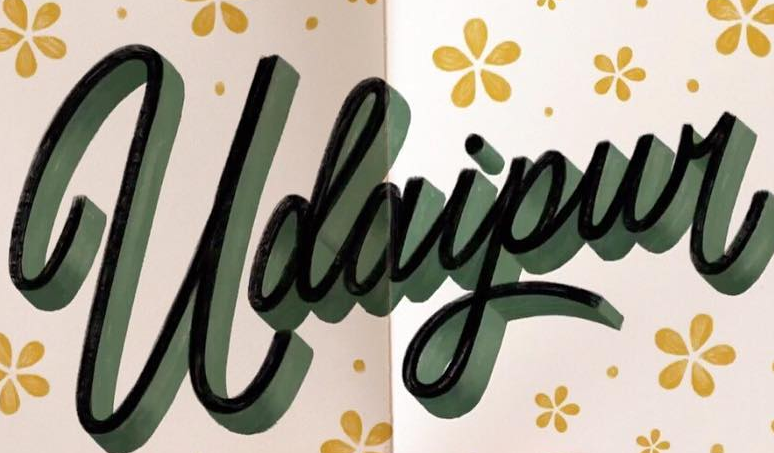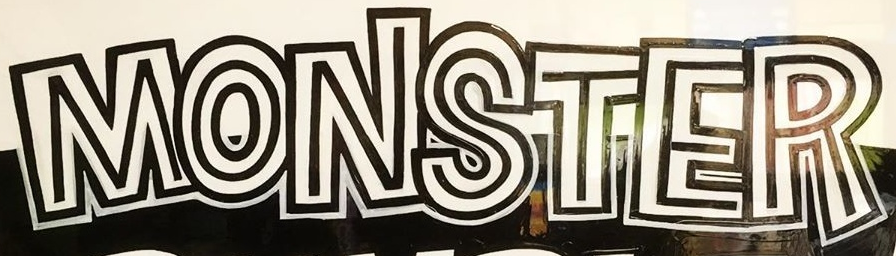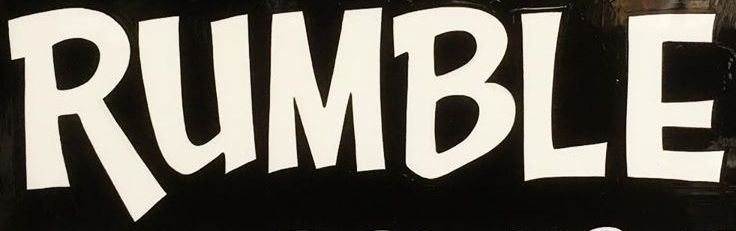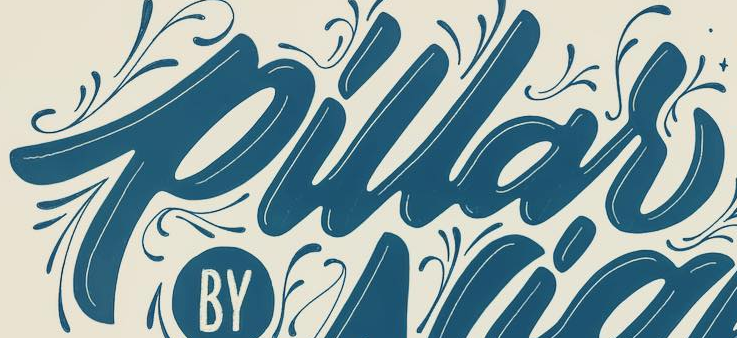What words can you see in these images in sequence, separated by a semicolon? Udaipur; MONSTER; RUMBLE; pillar 